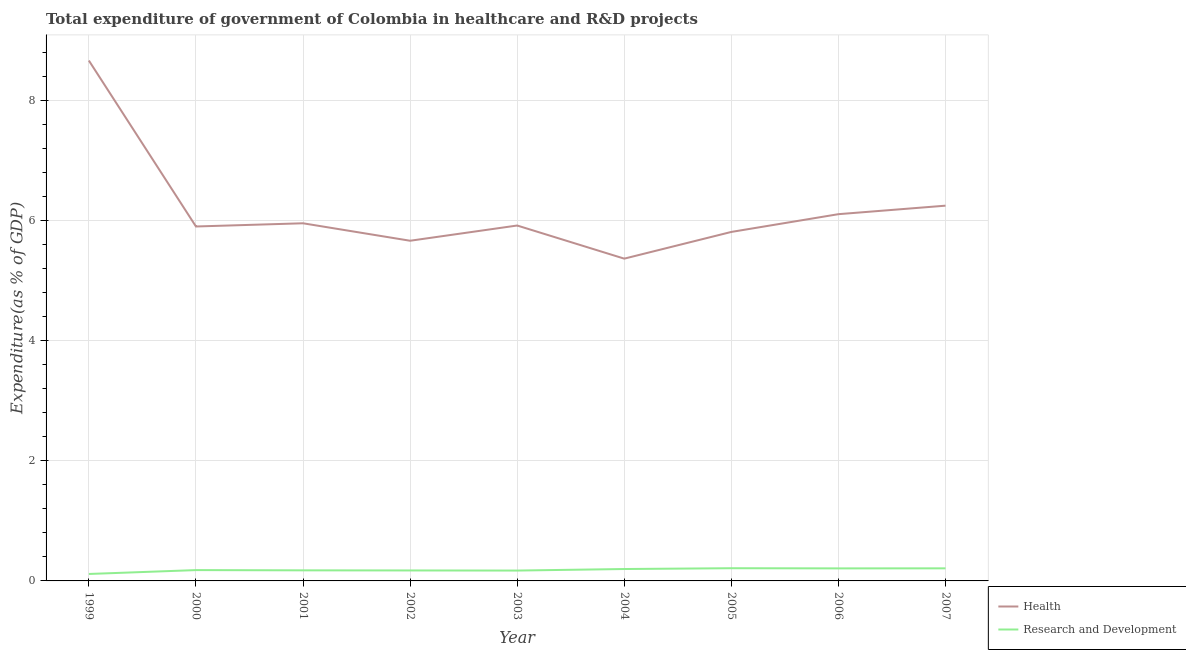How many different coloured lines are there?
Give a very brief answer. 2. Is the number of lines equal to the number of legend labels?
Ensure brevity in your answer.  Yes. What is the expenditure in r&d in 2002?
Ensure brevity in your answer.  0.17. Across all years, what is the maximum expenditure in healthcare?
Your response must be concise. 8.67. Across all years, what is the minimum expenditure in r&d?
Provide a succinct answer. 0.12. In which year was the expenditure in r&d maximum?
Your response must be concise. 2005. What is the total expenditure in r&d in the graph?
Give a very brief answer. 1.65. What is the difference between the expenditure in healthcare in 2000 and that in 2001?
Your response must be concise. -0.05. What is the difference between the expenditure in r&d in 2004 and the expenditure in healthcare in 1999?
Make the answer very short. -8.47. What is the average expenditure in healthcare per year?
Provide a succinct answer. 6.19. In the year 2006, what is the difference between the expenditure in r&d and expenditure in healthcare?
Ensure brevity in your answer.  -5.9. In how many years, is the expenditure in healthcare greater than 5.6 %?
Give a very brief answer. 8. What is the ratio of the expenditure in healthcare in 2002 to that in 2005?
Provide a succinct answer. 0.97. What is the difference between the highest and the second highest expenditure in healthcare?
Offer a very short reply. 2.42. What is the difference between the highest and the lowest expenditure in healthcare?
Make the answer very short. 3.3. Is the expenditure in r&d strictly greater than the expenditure in healthcare over the years?
Offer a terse response. No. Is the expenditure in healthcare strictly less than the expenditure in r&d over the years?
Ensure brevity in your answer.  No. How many lines are there?
Provide a short and direct response. 2. How many years are there in the graph?
Give a very brief answer. 9. Does the graph contain grids?
Give a very brief answer. Yes. How are the legend labels stacked?
Your response must be concise. Vertical. What is the title of the graph?
Make the answer very short. Total expenditure of government of Colombia in healthcare and R&D projects. What is the label or title of the X-axis?
Ensure brevity in your answer.  Year. What is the label or title of the Y-axis?
Your response must be concise. Expenditure(as % of GDP). What is the Expenditure(as % of GDP) in Health in 1999?
Give a very brief answer. 8.67. What is the Expenditure(as % of GDP) of Research and Development in 1999?
Offer a terse response. 0.12. What is the Expenditure(as % of GDP) of Health in 2000?
Offer a terse response. 5.91. What is the Expenditure(as % of GDP) of Research and Development in 2000?
Make the answer very short. 0.18. What is the Expenditure(as % of GDP) in Health in 2001?
Offer a terse response. 5.96. What is the Expenditure(as % of GDP) in Research and Development in 2001?
Provide a short and direct response. 0.18. What is the Expenditure(as % of GDP) of Health in 2002?
Give a very brief answer. 5.67. What is the Expenditure(as % of GDP) in Research and Development in 2002?
Give a very brief answer. 0.17. What is the Expenditure(as % of GDP) in Health in 2003?
Give a very brief answer. 5.92. What is the Expenditure(as % of GDP) in Research and Development in 2003?
Make the answer very short. 0.17. What is the Expenditure(as % of GDP) in Health in 2004?
Provide a short and direct response. 5.37. What is the Expenditure(as % of GDP) of Research and Development in 2004?
Your answer should be very brief. 0.2. What is the Expenditure(as % of GDP) in Health in 2005?
Your answer should be very brief. 5.82. What is the Expenditure(as % of GDP) of Research and Development in 2005?
Provide a succinct answer. 0.21. What is the Expenditure(as % of GDP) in Health in 2006?
Ensure brevity in your answer.  6.11. What is the Expenditure(as % of GDP) in Research and Development in 2006?
Your answer should be very brief. 0.21. What is the Expenditure(as % of GDP) of Health in 2007?
Your response must be concise. 6.25. What is the Expenditure(as % of GDP) in Research and Development in 2007?
Offer a very short reply. 0.21. Across all years, what is the maximum Expenditure(as % of GDP) of Health?
Provide a short and direct response. 8.67. Across all years, what is the maximum Expenditure(as % of GDP) of Research and Development?
Make the answer very short. 0.21. Across all years, what is the minimum Expenditure(as % of GDP) in Health?
Your answer should be very brief. 5.37. Across all years, what is the minimum Expenditure(as % of GDP) of Research and Development?
Keep it short and to the point. 0.12. What is the total Expenditure(as % of GDP) of Health in the graph?
Give a very brief answer. 55.68. What is the total Expenditure(as % of GDP) of Research and Development in the graph?
Make the answer very short. 1.65. What is the difference between the Expenditure(as % of GDP) of Health in 1999 and that in 2000?
Keep it short and to the point. 2.77. What is the difference between the Expenditure(as % of GDP) in Research and Development in 1999 and that in 2000?
Ensure brevity in your answer.  -0.06. What is the difference between the Expenditure(as % of GDP) in Health in 1999 and that in 2001?
Offer a terse response. 2.71. What is the difference between the Expenditure(as % of GDP) in Research and Development in 1999 and that in 2001?
Offer a terse response. -0.06. What is the difference between the Expenditure(as % of GDP) in Health in 1999 and that in 2002?
Keep it short and to the point. 3. What is the difference between the Expenditure(as % of GDP) of Research and Development in 1999 and that in 2002?
Your response must be concise. -0.06. What is the difference between the Expenditure(as % of GDP) of Health in 1999 and that in 2003?
Your response must be concise. 2.75. What is the difference between the Expenditure(as % of GDP) in Research and Development in 1999 and that in 2003?
Offer a terse response. -0.06. What is the difference between the Expenditure(as % of GDP) of Health in 1999 and that in 2004?
Give a very brief answer. 3.3. What is the difference between the Expenditure(as % of GDP) in Research and Development in 1999 and that in 2004?
Provide a short and direct response. -0.08. What is the difference between the Expenditure(as % of GDP) in Health in 1999 and that in 2005?
Provide a short and direct response. 2.86. What is the difference between the Expenditure(as % of GDP) of Research and Development in 1999 and that in 2005?
Provide a short and direct response. -0.1. What is the difference between the Expenditure(as % of GDP) in Health in 1999 and that in 2006?
Keep it short and to the point. 2.56. What is the difference between the Expenditure(as % of GDP) of Research and Development in 1999 and that in 2006?
Offer a terse response. -0.09. What is the difference between the Expenditure(as % of GDP) of Health in 1999 and that in 2007?
Offer a terse response. 2.42. What is the difference between the Expenditure(as % of GDP) in Research and Development in 1999 and that in 2007?
Offer a very short reply. -0.09. What is the difference between the Expenditure(as % of GDP) in Health in 2000 and that in 2001?
Your answer should be very brief. -0.05. What is the difference between the Expenditure(as % of GDP) of Research and Development in 2000 and that in 2001?
Your answer should be compact. 0. What is the difference between the Expenditure(as % of GDP) in Health in 2000 and that in 2002?
Provide a succinct answer. 0.24. What is the difference between the Expenditure(as % of GDP) in Research and Development in 2000 and that in 2002?
Provide a short and direct response. 0.01. What is the difference between the Expenditure(as % of GDP) in Health in 2000 and that in 2003?
Offer a terse response. -0.02. What is the difference between the Expenditure(as % of GDP) of Research and Development in 2000 and that in 2003?
Provide a short and direct response. 0.01. What is the difference between the Expenditure(as % of GDP) in Health in 2000 and that in 2004?
Ensure brevity in your answer.  0.54. What is the difference between the Expenditure(as % of GDP) of Research and Development in 2000 and that in 2004?
Keep it short and to the point. -0.02. What is the difference between the Expenditure(as % of GDP) in Health in 2000 and that in 2005?
Your answer should be compact. 0.09. What is the difference between the Expenditure(as % of GDP) of Research and Development in 2000 and that in 2005?
Keep it short and to the point. -0.03. What is the difference between the Expenditure(as % of GDP) of Health in 2000 and that in 2006?
Offer a very short reply. -0.21. What is the difference between the Expenditure(as % of GDP) of Research and Development in 2000 and that in 2006?
Your answer should be very brief. -0.03. What is the difference between the Expenditure(as % of GDP) in Health in 2000 and that in 2007?
Your answer should be very brief. -0.35. What is the difference between the Expenditure(as % of GDP) in Research and Development in 2000 and that in 2007?
Make the answer very short. -0.03. What is the difference between the Expenditure(as % of GDP) in Health in 2001 and that in 2002?
Provide a succinct answer. 0.29. What is the difference between the Expenditure(as % of GDP) of Research and Development in 2001 and that in 2002?
Your response must be concise. 0. What is the difference between the Expenditure(as % of GDP) in Health in 2001 and that in 2003?
Give a very brief answer. 0.04. What is the difference between the Expenditure(as % of GDP) of Research and Development in 2001 and that in 2003?
Provide a short and direct response. 0. What is the difference between the Expenditure(as % of GDP) in Health in 2001 and that in 2004?
Offer a terse response. 0.59. What is the difference between the Expenditure(as % of GDP) in Research and Development in 2001 and that in 2004?
Your answer should be compact. -0.02. What is the difference between the Expenditure(as % of GDP) in Health in 2001 and that in 2005?
Your response must be concise. 0.14. What is the difference between the Expenditure(as % of GDP) in Research and Development in 2001 and that in 2005?
Your response must be concise. -0.04. What is the difference between the Expenditure(as % of GDP) in Health in 2001 and that in 2006?
Your answer should be very brief. -0.15. What is the difference between the Expenditure(as % of GDP) of Research and Development in 2001 and that in 2006?
Provide a short and direct response. -0.03. What is the difference between the Expenditure(as % of GDP) of Health in 2001 and that in 2007?
Offer a terse response. -0.29. What is the difference between the Expenditure(as % of GDP) of Research and Development in 2001 and that in 2007?
Offer a very short reply. -0.03. What is the difference between the Expenditure(as % of GDP) in Health in 2002 and that in 2003?
Make the answer very short. -0.25. What is the difference between the Expenditure(as % of GDP) in Research and Development in 2002 and that in 2003?
Make the answer very short. 0. What is the difference between the Expenditure(as % of GDP) in Health in 2002 and that in 2004?
Ensure brevity in your answer.  0.3. What is the difference between the Expenditure(as % of GDP) of Research and Development in 2002 and that in 2004?
Your response must be concise. -0.02. What is the difference between the Expenditure(as % of GDP) in Health in 2002 and that in 2005?
Keep it short and to the point. -0.15. What is the difference between the Expenditure(as % of GDP) of Research and Development in 2002 and that in 2005?
Provide a short and direct response. -0.04. What is the difference between the Expenditure(as % of GDP) of Health in 2002 and that in 2006?
Give a very brief answer. -0.44. What is the difference between the Expenditure(as % of GDP) in Research and Development in 2002 and that in 2006?
Your answer should be compact. -0.03. What is the difference between the Expenditure(as % of GDP) in Health in 2002 and that in 2007?
Offer a very short reply. -0.58. What is the difference between the Expenditure(as % of GDP) of Research and Development in 2002 and that in 2007?
Offer a terse response. -0.04. What is the difference between the Expenditure(as % of GDP) in Health in 2003 and that in 2004?
Offer a terse response. 0.55. What is the difference between the Expenditure(as % of GDP) of Research and Development in 2003 and that in 2004?
Your answer should be very brief. -0.03. What is the difference between the Expenditure(as % of GDP) in Health in 2003 and that in 2005?
Ensure brevity in your answer.  0.11. What is the difference between the Expenditure(as % of GDP) in Research and Development in 2003 and that in 2005?
Keep it short and to the point. -0.04. What is the difference between the Expenditure(as % of GDP) of Health in 2003 and that in 2006?
Offer a very short reply. -0.19. What is the difference between the Expenditure(as % of GDP) of Research and Development in 2003 and that in 2006?
Offer a very short reply. -0.04. What is the difference between the Expenditure(as % of GDP) in Health in 2003 and that in 2007?
Your answer should be very brief. -0.33. What is the difference between the Expenditure(as % of GDP) of Research and Development in 2003 and that in 2007?
Keep it short and to the point. -0.04. What is the difference between the Expenditure(as % of GDP) in Health in 2004 and that in 2005?
Offer a terse response. -0.45. What is the difference between the Expenditure(as % of GDP) of Research and Development in 2004 and that in 2005?
Offer a terse response. -0.01. What is the difference between the Expenditure(as % of GDP) in Health in 2004 and that in 2006?
Offer a very short reply. -0.74. What is the difference between the Expenditure(as % of GDP) in Research and Development in 2004 and that in 2006?
Make the answer very short. -0.01. What is the difference between the Expenditure(as % of GDP) in Health in 2004 and that in 2007?
Ensure brevity in your answer.  -0.88. What is the difference between the Expenditure(as % of GDP) in Research and Development in 2004 and that in 2007?
Offer a very short reply. -0.01. What is the difference between the Expenditure(as % of GDP) of Health in 2005 and that in 2006?
Offer a very short reply. -0.3. What is the difference between the Expenditure(as % of GDP) in Research and Development in 2005 and that in 2006?
Offer a very short reply. 0. What is the difference between the Expenditure(as % of GDP) of Health in 2005 and that in 2007?
Ensure brevity in your answer.  -0.44. What is the difference between the Expenditure(as % of GDP) of Research and Development in 2005 and that in 2007?
Keep it short and to the point. 0. What is the difference between the Expenditure(as % of GDP) in Health in 2006 and that in 2007?
Ensure brevity in your answer.  -0.14. What is the difference between the Expenditure(as % of GDP) of Research and Development in 2006 and that in 2007?
Your response must be concise. -0. What is the difference between the Expenditure(as % of GDP) of Health in 1999 and the Expenditure(as % of GDP) of Research and Development in 2000?
Make the answer very short. 8.49. What is the difference between the Expenditure(as % of GDP) of Health in 1999 and the Expenditure(as % of GDP) of Research and Development in 2001?
Give a very brief answer. 8.5. What is the difference between the Expenditure(as % of GDP) in Health in 1999 and the Expenditure(as % of GDP) in Research and Development in 2002?
Make the answer very short. 8.5. What is the difference between the Expenditure(as % of GDP) of Health in 1999 and the Expenditure(as % of GDP) of Research and Development in 2003?
Offer a very short reply. 8.5. What is the difference between the Expenditure(as % of GDP) in Health in 1999 and the Expenditure(as % of GDP) in Research and Development in 2004?
Provide a short and direct response. 8.47. What is the difference between the Expenditure(as % of GDP) of Health in 1999 and the Expenditure(as % of GDP) of Research and Development in 2005?
Offer a terse response. 8.46. What is the difference between the Expenditure(as % of GDP) of Health in 1999 and the Expenditure(as % of GDP) of Research and Development in 2006?
Offer a very short reply. 8.46. What is the difference between the Expenditure(as % of GDP) in Health in 1999 and the Expenditure(as % of GDP) in Research and Development in 2007?
Make the answer very short. 8.46. What is the difference between the Expenditure(as % of GDP) of Health in 2000 and the Expenditure(as % of GDP) of Research and Development in 2001?
Your response must be concise. 5.73. What is the difference between the Expenditure(as % of GDP) of Health in 2000 and the Expenditure(as % of GDP) of Research and Development in 2002?
Keep it short and to the point. 5.73. What is the difference between the Expenditure(as % of GDP) in Health in 2000 and the Expenditure(as % of GDP) in Research and Development in 2003?
Your response must be concise. 5.73. What is the difference between the Expenditure(as % of GDP) of Health in 2000 and the Expenditure(as % of GDP) of Research and Development in 2004?
Provide a succinct answer. 5.71. What is the difference between the Expenditure(as % of GDP) in Health in 2000 and the Expenditure(as % of GDP) in Research and Development in 2005?
Offer a terse response. 5.69. What is the difference between the Expenditure(as % of GDP) in Health in 2000 and the Expenditure(as % of GDP) in Research and Development in 2006?
Your answer should be compact. 5.7. What is the difference between the Expenditure(as % of GDP) in Health in 2000 and the Expenditure(as % of GDP) in Research and Development in 2007?
Your response must be concise. 5.7. What is the difference between the Expenditure(as % of GDP) in Health in 2001 and the Expenditure(as % of GDP) in Research and Development in 2002?
Your answer should be compact. 5.79. What is the difference between the Expenditure(as % of GDP) of Health in 2001 and the Expenditure(as % of GDP) of Research and Development in 2003?
Make the answer very short. 5.79. What is the difference between the Expenditure(as % of GDP) in Health in 2001 and the Expenditure(as % of GDP) in Research and Development in 2004?
Offer a terse response. 5.76. What is the difference between the Expenditure(as % of GDP) in Health in 2001 and the Expenditure(as % of GDP) in Research and Development in 2005?
Your answer should be compact. 5.75. What is the difference between the Expenditure(as % of GDP) in Health in 2001 and the Expenditure(as % of GDP) in Research and Development in 2006?
Offer a terse response. 5.75. What is the difference between the Expenditure(as % of GDP) of Health in 2001 and the Expenditure(as % of GDP) of Research and Development in 2007?
Your answer should be very brief. 5.75. What is the difference between the Expenditure(as % of GDP) in Health in 2002 and the Expenditure(as % of GDP) in Research and Development in 2003?
Your answer should be compact. 5.5. What is the difference between the Expenditure(as % of GDP) in Health in 2002 and the Expenditure(as % of GDP) in Research and Development in 2004?
Your answer should be very brief. 5.47. What is the difference between the Expenditure(as % of GDP) of Health in 2002 and the Expenditure(as % of GDP) of Research and Development in 2005?
Make the answer very short. 5.46. What is the difference between the Expenditure(as % of GDP) in Health in 2002 and the Expenditure(as % of GDP) in Research and Development in 2006?
Provide a succinct answer. 5.46. What is the difference between the Expenditure(as % of GDP) in Health in 2002 and the Expenditure(as % of GDP) in Research and Development in 2007?
Your answer should be very brief. 5.46. What is the difference between the Expenditure(as % of GDP) in Health in 2003 and the Expenditure(as % of GDP) in Research and Development in 2004?
Give a very brief answer. 5.72. What is the difference between the Expenditure(as % of GDP) in Health in 2003 and the Expenditure(as % of GDP) in Research and Development in 2005?
Keep it short and to the point. 5.71. What is the difference between the Expenditure(as % of GDP) in Health in 2003 and the Expenditure(as % of GDP) in Research and Development in 2006?
Your response must be concise. 5.71. What is the difference between the Expenditure(as % of GDP) of Health in 2003 and the Expenditure(as % of GDP) of Research and Development in 2007?
Keep it short and to the point. 5.71. What is the difference between the Expenditure(as % of GDP) of Health in 2004 and the Expenditure(as % of GDP) of Research and Development in 2005?
Offer a very short reply. 5.16. What is the difference between the Expenditure(as % of GDP) of Health in 2004 and the Expenditure(as % of GDP) of Research and Development in 2006?
Make the answer very short. 5.16. What is the difference between the Expenditure(as % of GDP) in Health in 2004 and the Expenditure(as % of GDP) in Research and Development in 2007?
Offer a very short reply. 5.16. What is the difference between the Expenditure(as % of GDP) of Health in 2005 and the Expenditure(as % of GDP) of Research and Development in 2006?
Provide a short and direct response. 5.61. What is the difference between the Expenditure(as % of GDP) of Health in 2005 and the Expenditure(as % of GDP) of Research and Development in 2007?
Your answer should be very brief. 5.61. What is the difference between the Expenditure(as % of GDP) in Health in 2006 and the Expenditure(as % of GDP) in Research and Development in 2007?
Give a very brief answer. 5.9. What is the average Expenditure(as % of GDP) of Health per year?
Your answer should be compact. 6.19. What is the average Expenditure(as % of GDP) in Research and Development per year?
Offer a very short reply. 0.18. In the year 1999, what is the difference between the Expenditure(as % of GDP) in Health and Expenditure(as % of GDP) in Research and Development?
Your response must be concise. 8.56. In the year 2000, what is the difference between the Expenditure(as % of GDP) of Health and Expenditure(as % of GDP) of Research and Development?
Provide a succinct answer. 5.73. In the year 2001, what is the difference between the Expenditure(as % of GDP) in Health and Expenditure(as % of GDP) in Research and Development?
Provide a short and direct response. 5.78. In the year 2002, what is the difference between the Expenditure(as % of GDP) of Health and Expenditure(as % of GDP) of Research and Development?
Offer a very short reply. 5.49. In the year 2003, what is the difference between the Expenditure(as % of GDP) of Health and Expenditure(as % of GDP) of Research and Development?
Offer a terse response. 5.75. In the year 2004, what is the difference between the Expenditure(as % of GDP) in Health and Expenditure(as % of GDP) in Research and Development?
Your response must be concise. 5.17. In the year 2005, what is the difference between the Expenditure(as % of GDP) in Health and Expenditure(as % of GDP) in Research and Development?
Provide a succinct answer. 5.6. In the year 2006, what is the difference between the Expenditure(as % of GDP) of Health and Expenditure(as % of GDP) of Research and Development?
Keep it short and to the point. 5.9. In the year 2007, what is the difference between the Expenditure(as % of GDP) in Health and Expenditure(as % of GDP) in Research and Development?
Offer a terse response. 6.04. What is the ratio of the Expenditure(as % of GDP) in Health in 1999 to that in 2000?
Give a very brief answer. 1.47. What is the ratio of the Expenditure(as % of GDP) in Research and Development in 1999 to that in 2000?
Your answer should be very brief. 0.64. What is the ratio of the Expenditure(as % of GDP) in Health in 1999 to that in 2001?
Provide a short and direct response. 1.46. What is the ratio of the Expenditure(as % of GDP) in Research and Development in 1999 to that in 2001?
Offer a very short reply. 0.66. What is the ratio of the Expenditure(as % of GDP) of Health in 1999 to that in 2002?
Your response must be concise. 1.53. What is the ratio of the Expenditure(as % of GDP) of Research and Development in 1999 to that in 2002?
Provide a short and direct response. 0.66. What is the ratio of the Expenditure(as % of GDP) of Health in 1999 to that in 2003?
Provide a succinct answer. 1.46. What is the ratio of the Expenditure(as % of GDP) of Research and Development in 1999 to that in 2003?
Provide a short and direct response. 0.67. What is the ratio of the Expenditure(as % of GDP) of Health in 1999 to that in 2004?
Provide a short and direct response. 1.61. What is the ratio of the Expenditure(as % of GDP) in Research and Development in 1999 to that in 2004?
Your answer should be compact. 0.58. What is the ratio of the Expenditure(as % of GDP) of Health in 1999 to that in 2005?
Ensure brevity in your answer.  1.49. What is the ratio of the Expenditure(as % of GDP) of Research and Development in 1999 to that in 2005?
Keep it short and to the point. 0.55. What is the ratio of the Expenditure(as % of GDP) of Health in 1999 to that in 2006?
Keep it short and to the point. 1.42. What is the ratio of the Expenditure(as % of GDP) of Research and Development in 1999 to that in 2006?
Offer a terse response. 0.56. What is the ratio of the Expenditure(as % of GDP) in Health in 1999 to that in 2007?
Your answer should be compact. 1.39. What is the ratio of the Expenditure(as % of GDP) in Research and Development in 1999 to that in 2007?
Provide a succinct answer. 0.55. What is the ratio of the Expenditure(as % of GDP) in Research and Development in 2000 to that in 2001?
Your answer should be compact. 1.02. What is the ratio of the Expenditure(as % of GDP) in Health in 2000 to that in 2002?
Offer a terse response. 1.04. What is the ratio of the Expenditure(as % of GDP) in Research and Development in 2000 to that in 2002?
Keep it short and to the point. 1.03. What is the ratio of the Expenditure(as % of GDP) of Health in 2000 to that in 2003?
Keep it short and to the point. 1. What is the ratio of the Expenditure(as % of GDP) of Research and Development in 2000 to that in 2003?
Your answer should be very brief. 1.04. What is the ratio of the Expenditure(as % of GDP) of Health in 2000 to that in 2004?
Provide a short and direct response. 1.1. What is the ratio of the Expenditure(as % of GDP) of Research and Development in 2000 to that in 2004?
Offer a terse response. 0.91. What is the ratio of the Expenditure(as % of GDP) of Health in 2000 to that in 2005?
Your response must be concise. 1.02. What is the ratio of the Expenditure(as % of GDP) of Research and Development in 2000 to that in 2005?
Provide a succinct answer. 0.85. What is the ratio of the Expenditure(as % of GDP) in Health in 2000 to that in 2006?
Offer a very short reply. 0.97. What is the ratio of the Expenditure(as % of GDP) of Research and Development in 2000 to that in 2006?
Your answer should be very brief. 0.86. What is the ratio of the Expenditure(as % of GDP) in Health in 2000 to that in 2007?
Provide a short and direct response. 0.94. What is the ratio of the Expenditure(as % of GDP) of Research and Development in 2000 to that in 2007?
Offer a terse response. 0.86. What is the ratio of the Expenditure(as % of GDP) in Health in 2001 to that in 2002?
Give a very brief answer. 1.05. What is the ratio of the Expenditure(as % of GDP) of Research and Development in 2001 to that in 2002?
Make the answer very short. 1.01. What is the ratio of the Expenditure(as % of GDP) of Research and Development in 2001 to that in 2003?
Your response must be concise. 1.02. What is the ratio of the Expenditure(as % of GDP) in Health in 2001 to that in 2004?
Give a very brief answer. 1.11. What is the ratio of the Expenditure(as % of GDP) of Research and Development in 2001 to that in 2004?
Keep it short and to the point. 0.89. What is the ratio of the Expenditure(as % of GDP) in Health in 2001 to that in 2005?
Your answer should be very brief. 1.02. What is the ratio of the Expenditure(as % of GDP) of Research and Development in 2001 to that in 2005?
Offer a very short reply. 0.83. What is the ratio of the Expenditure(as % of GDP) of Health in 2001 to that in 2006?
Keep it short and to the point. 0.98. What is the ratio of the Expenditure(as % of GDP) of Research and Development in 2001 to that in 2006?
Keep it short and to the point. 0.84. What is the ratio of the Expenditure(as % of GDP) of Health in 2001 to that in 2007?
Offer a terse response. 0.95. What is the ratio of the Expenditure(as % of GDP) in Research and Development in 2001 to that in 2007?
Ensure brevity in your answer.  0.84. What is the ratio of the Expenditure(as % of GDP) of Health in 2002 to that in 2003?
Your response must be concise. 0.96. What is the ratio of the Expenditure(as % of GDP) of Research and Development in 2002 to that in 2003?
Your answer should be compact. 1.01. What is the ratio of the Expenditure(as % of GDP) in Health in 2002 to that in 2004?
Offer a very short reply. 1.06. What is the ratio of the Expenditure(as % of GDP) in Research and Development in 2002 to that in 2004?
Offer a very short reply. 0.88. What is the ratio of the Expenditure(as % of GDP) in Health in 2002 to that in 2005?
Your answer should be compact. 0.97. What is the ratio of the Expenditure(as % of GDP) of Research and Development in 2002 to that in 2005?
Offer a terse response. 0.82. What is the ratio of the Expenditure(as % of GDP) of Health in 2002 to that in 2006?
Give a very brief answer. 0.93. What is the ratio of the Expenditure(as % of GDP) of Research and Development in 2002 to that in 2006?
Provide a succinct answer. 0.84. What is the ratio of the Expenditure(as % of GDP) in Health in 2002 to that in 2007?
Make the answer very short. 0.91. What is the ratio of the Expenditure(as % of GDP) of Research and Development in 2002 to that in 2007?
Ensure brevity in your answer.  0.83. What is the ratio of the Expenditure(as % of GDP) in Health in 2003 to that in 2004?
Provide a succinct answer. 1.1. What is the ratio of the Expenditure(as % of GDP) of Research and Development in 2003 to that in 2004?
Your answer should be very brief. 0.87. What is the ratio of the Expenditure(as % of GDP) in Health in 2003 to that in 2005?
Give a very brief answer. 1.02. What is the ratio of the Expenditure(as % of GDP) of Research and Development in 2003 to that in 2005?
Make the answer very short. 0.82. What is the ratio of the Expenditure(as % of GDP) in Health in 2003 to that in 2006?
Your answer should be compact. 0.97. What is the ratio of the Expenditure(as % of GDP) of Research and Development in 2003 to that in 2006?
Your response must be concise. 0.83. What is the ratio of the Expenditure(as % of GDP) in Health in 2003 to that in 2007?
Give a very brief answer. 0.95. What is the ratio of the Expenditure(as % of GDP) of Research and Development in 2003 to that in 2007?
Provide a short and direct response. 0.82. What is the ratio of the Expenditure(as % of GDP) in Health in 2004 to that in 2005?
Make the answer very short. 0.92. What is the ratio of the Expenditure(as % of GDP) of Research and Development in 2004 to that in 2005?
Provide a succinct answer. 0.94. What is the ratio of the Expenditure(as % of GDP) in Health in 2004 to that in 2006?
Offer a very short reply. 0.88. What is the ratio of the Expenditure(as % of GDP) of Research and Development in 2004 to that in 2006?
Your response must be concise. 0.95. What is the ratio of the Expenditure(as % of GDP) of Health in 2004 to that in 2007?
Give a very brief answer. 0.86. What is the ratio of the Expenditure(as % of GDP) in Research and Development in 2004 to that in 2007?
Ensure brevity in your answer.  0.95. What is the ratio of the Expenditure(as % of GDP) in Health in 2005 to that in 2006?
Offer a terse response. 0.95. What is the ratio of the Expenditure(as % of GDP) in Research and Development in 2005 to that in 2006?
Offer a terse response. 1.01. What is the ratio of the Expenditure(as % of GDP) of Health in 2005 to that in 2007?
Ensure brevity in your answer.  0.93. What is the ratio of the Expenditure(as % of GDP) in Research and Development in 2005 to that in 2007?
Offer a very short reply. 1.01. What is the ratio of the Expenditure(as % of GDP) of Health in 2006 to that in 2007?
Keep it short and to the point. 0.98. What is the ratio of the Expenditure(as % of GDP) in Research and Development in 2006 to that in 2007?
Ensure brevity in your answer.  1. What is the difference between the highest and the second highest Expenditure(as % of GDP) in Health?
Keep it short and to the point. 2.42. What is the difference between the highest and the second highest Expenditure(as % of GDP) in Research and Development?
Your answer should be very brief. 0. What is the difference between the highest and the lowest Expenditure(as % of GDP) of Health?
Keep it short and to the point. 3.3. What is the difference between the highest and the lowest Expenditure(as % of GDP) of Research and Development?
Offer a terse response. 0.1. 